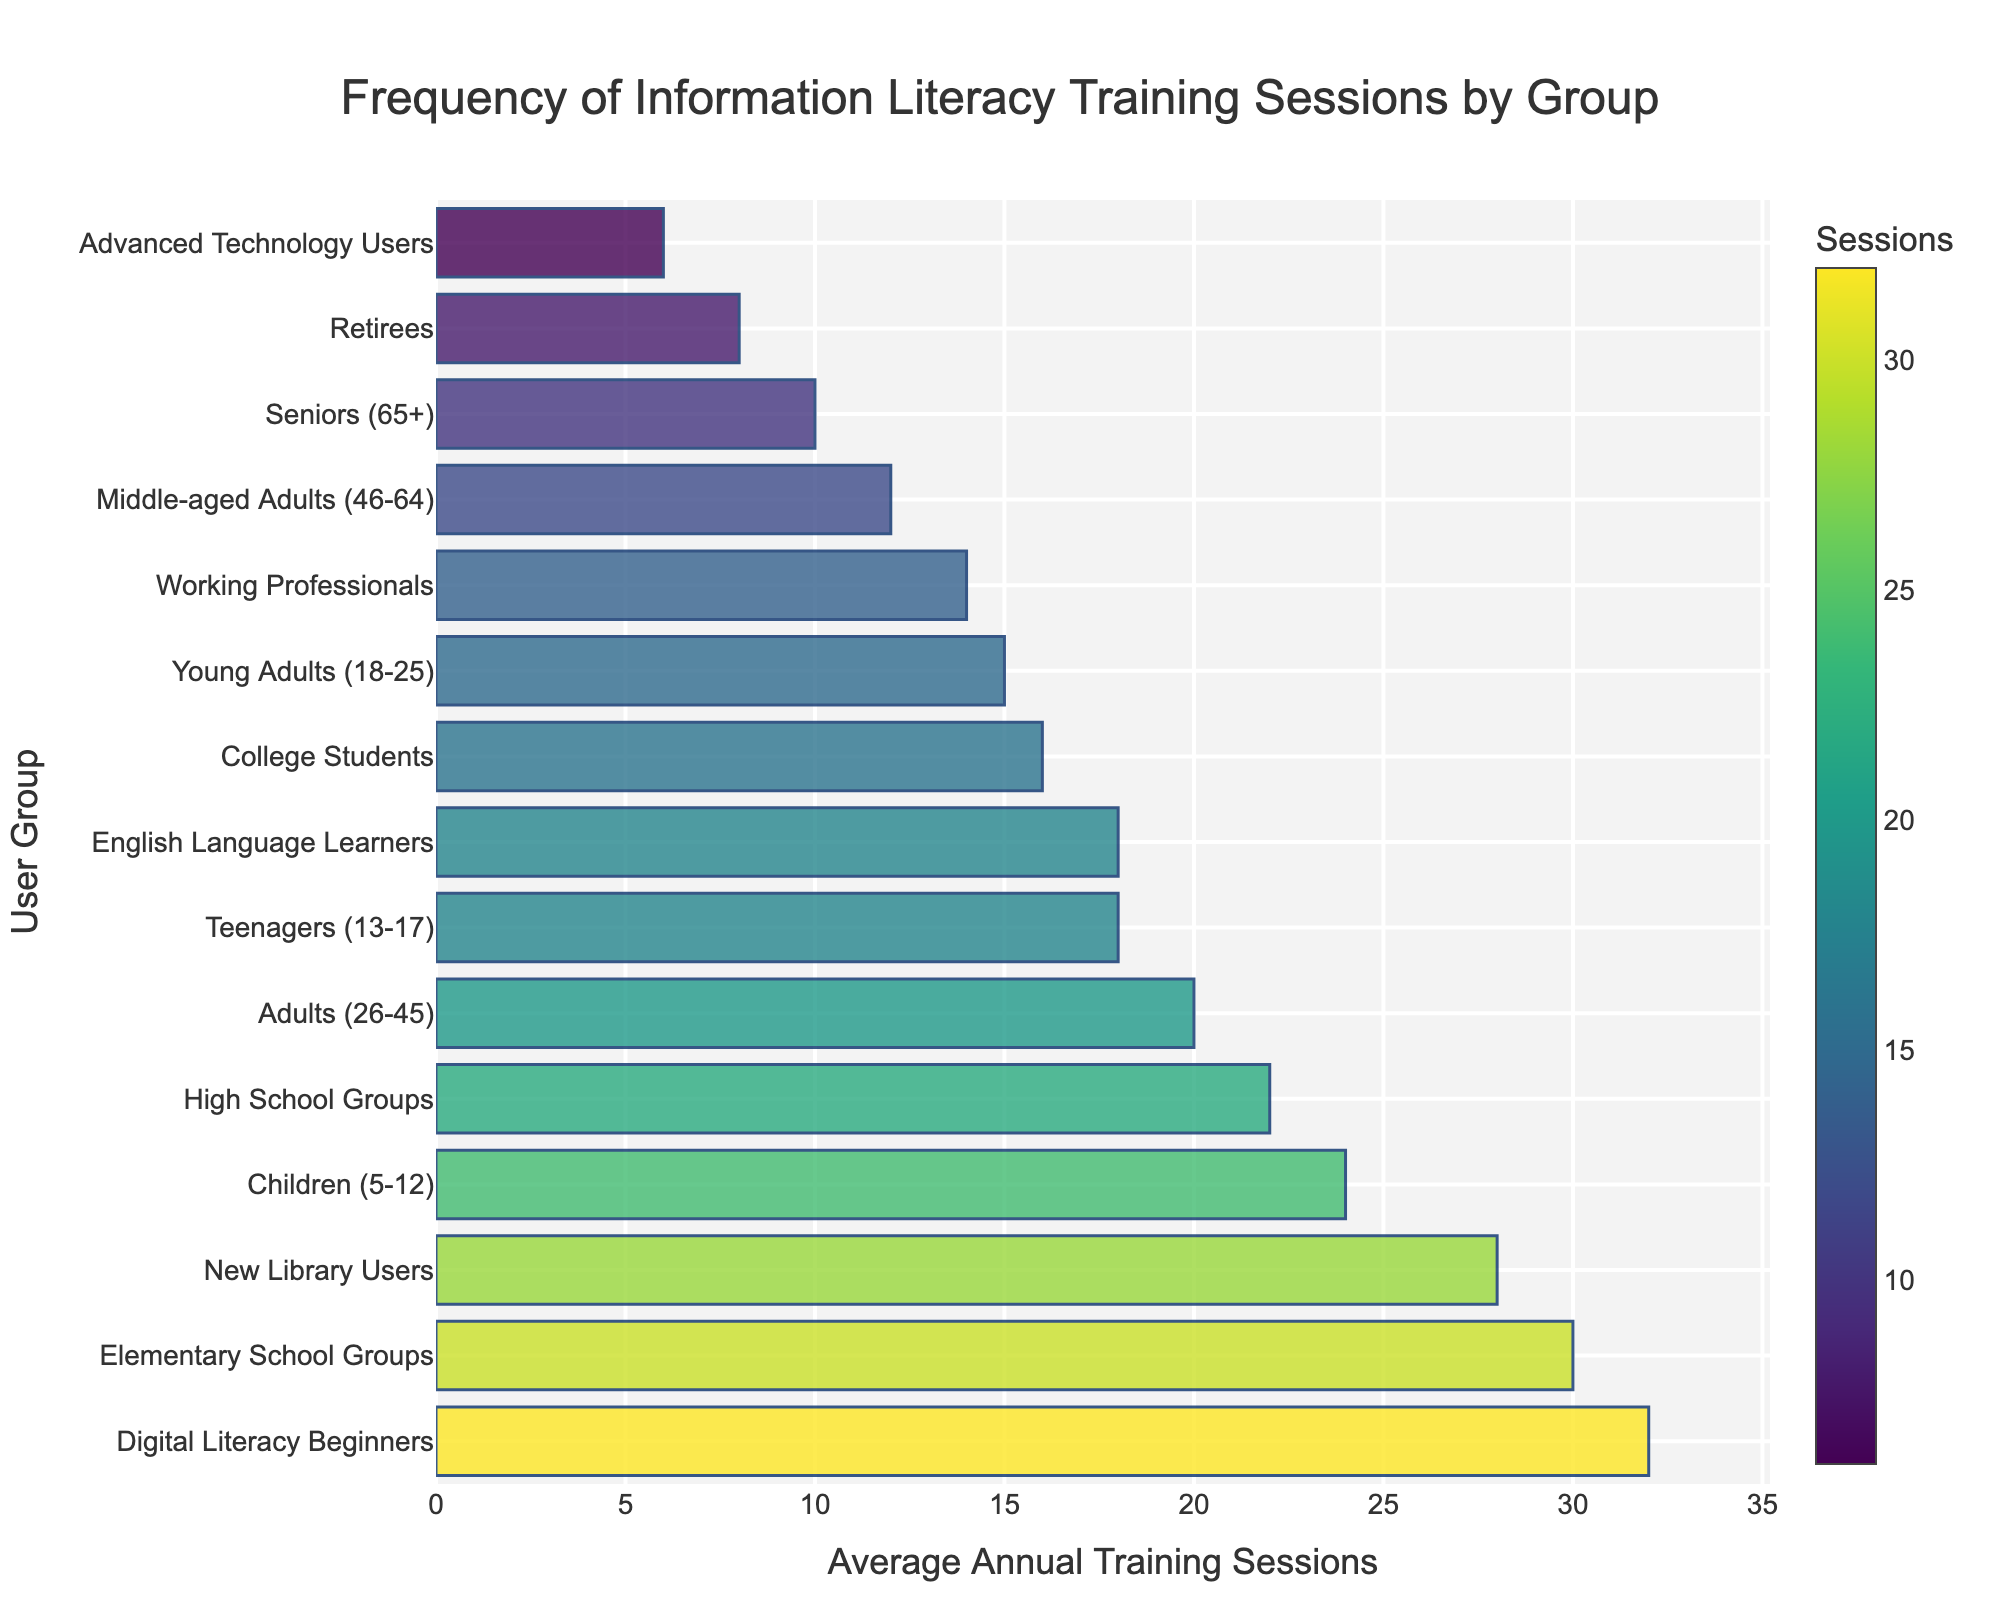What's the most frequently offered training session group? Identify the bar with the highest value and read its corresponding group name. The group at the top with the longest bar is "Digital Literacy Beginners" and has 32 sessions.
Answer: Digital Literacy Beginners How many more training sessions do Digital Literacy Beginners receive compared to Retirees? Find the values for both groups and subtract the number of sessions for Retirees (8) from the number of sessions for Digital Literacy Beginners (32). The difference is 32 - 8 = 24.
Answer: 24 Which age group has fewer average annual training sessions, Seniors or Advanced Technology Users? Compare the heights or values of the bars for Seniors (10) and Advanced Technology Users (6). The group with the smaller bar or value is Advanced Technology Users.
Answer: Advanced Technology Users What is the sum of average annual training sessions for the groups Children, Young Adults, and New Library Users? Add the numbers of sessions for these groups: Children (24) + Young Adults (15) + New Library Users (28) = 24 + 15 + 28 = 67.
Answer: 67 Is the number of sessions for High School Groups greater than that for College Students? Compare the values for High School Groups (22) and College Students (16). Since 22 is greater than 16, High School Groups have more sessions.
Answer: Yes What is the range of average annual training sessions offered across all groups? Calculate the range by subtracting the smallest value (Advanced Technology Users, 6) from the largest value (Digital Literacy Beginners, 32). The range is 32 - 6 = 26.
Answer: 26 Are there more training sessions for Working Professionals or for Adults? Compare the values for Working Professionals (14) and Adults (20). Adults have more with 20 sessions, compared to 14 for Working Professionals.
Answer: Adults What is the average number of annual training sessions for the groups with more than 20 sessions per year? Identify the groups with more than 20 sessions: Elementary School Groups (30), Digital Literacy Beginners (32), New Library Users (28), Children (24), and High School Groups (22). Calculate the average: (30 + 32 + 28 + 24 + 22) / 5 = 136 / 5 = 27.2.
Answer: 27.2 How does the frequency of sessions for English Language Learners compare visually to Young Adults? Observe the lengths and colors of the bars for English Language Learners (18) and Young Adults (15). The English Language Learners bar is slightly longer and will be darker in the color scale, indicating a higher number of sessions.
Answer: English Language Learners have more sessions Which bar is visually shortest and what group does it represent? Identify the bar with the smallest height/length, representing the lowest number, which is the bar for Advanced Technology Users (6). It will also be lighter in color compared to others.
Answer: Advanced Technology Users 